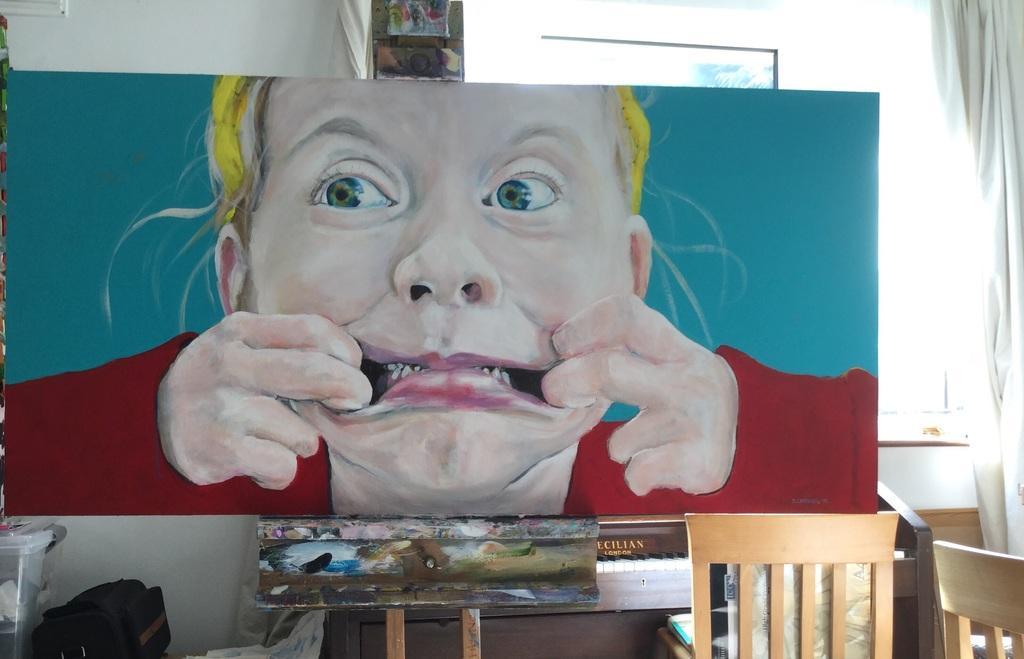Can you describe this image briefly? In this image I can see a board on a table. on this board I can see a painting of a person. At the bottom there are two chairs, a bag and some objects. On the right side, I can see a white color curtain. On the top of the image there is a wall. 